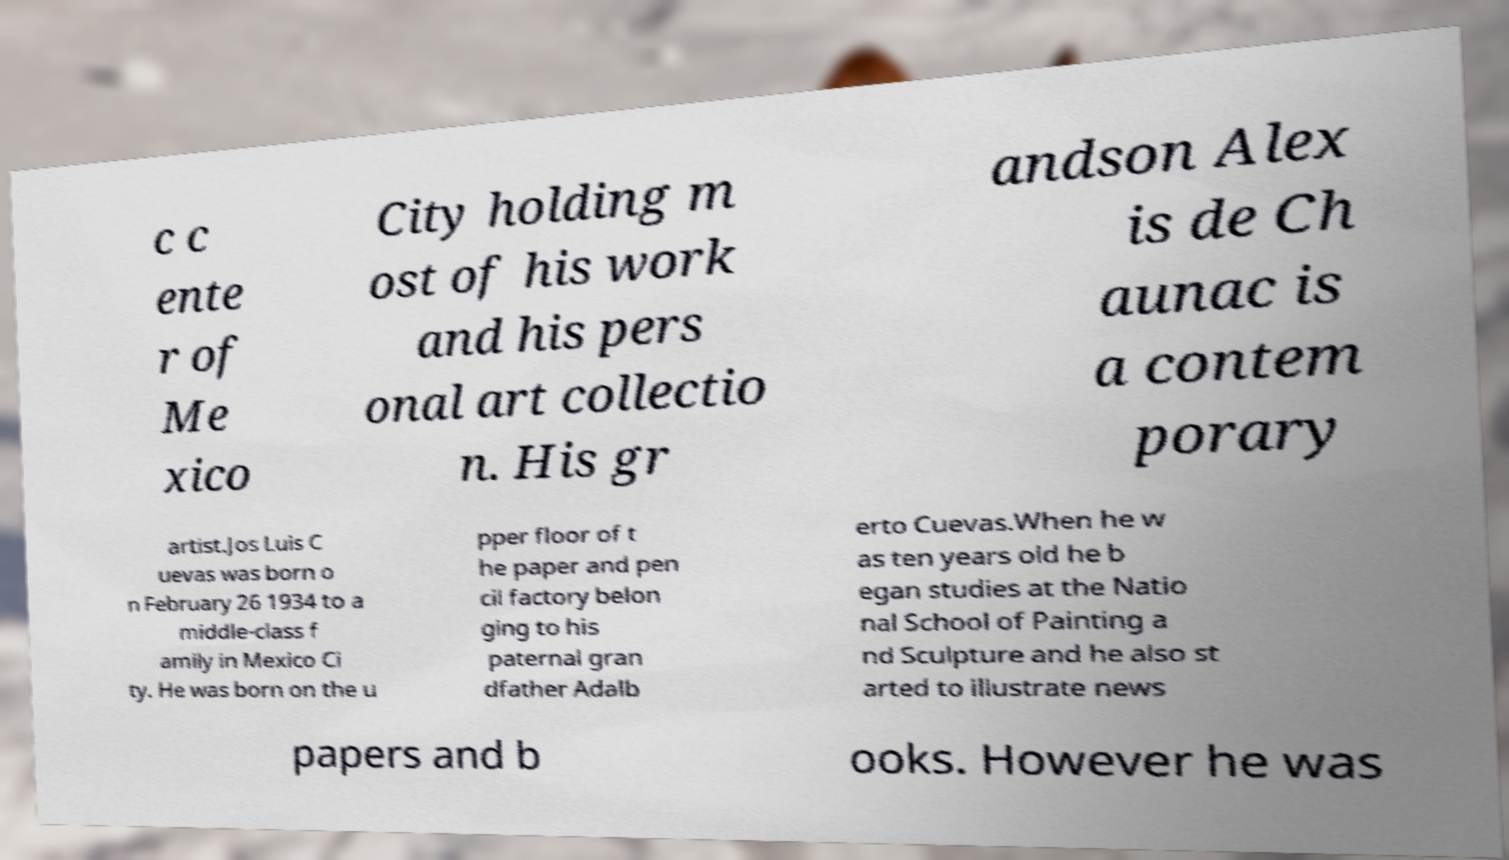Could you assist in decoding the text presented in this image and type it out clearly? c c ente r of Me xico City holding m ost of his work and his pers onal art collectio n. His gr andson Alex is de Ch aunac is a contem porary artist.Jos Luis C uevas was born o n February 26 1934 to a middle-class f amily in Mexico Ci ty. He was born on the u pper floor of t he paper and pen cil factory belon ging to his paternal gran dfather Adalb erto Cuevas.When he w as ten years old he b egan studies at the Natio nal School of Painting a nd Sculpture and he also st arted to illustrate news papers and b ooks. However he was 